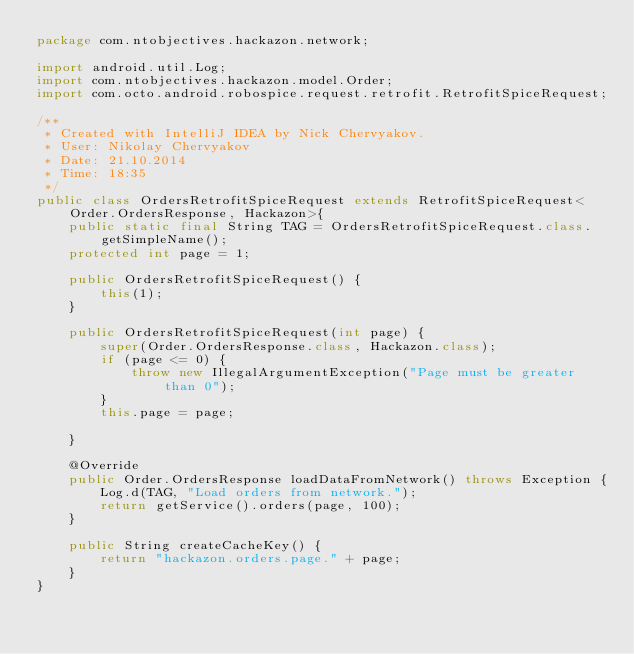Convert code to text. <code><loc_0><loc_0><loc_500><loc_500><_Java_>package com.ntobjectives.hackazon.network;

import android.util.Log;
import com.ntobjectives.hackazon.model.Order;
import com.octo.android.robospice.request.retrofit.RetrofitSpiceRequest;

/**
 * Created with IntelliJ IDEA by Nick Chervyakov.
 * User: Nikolay Chervyakov
 * Date: 21.10.2014
 * Time: 18:35
 */
public class OrdersRetrofitSpiceRequest extends RetrofitSpiceRequest<Order.OrdersResponse, Hackazon>{
    public static final String TAG = OrdersRetrofitSpiceRequest.class.getSimpleName();
    protected int page = 1;

    public OrdersRetrofitSpiceRequest() {
        this(1);
    }

    public OrdersRetrofitSpiceRequest(int page) {
        super(Order.OrdersResponse.class, Hackazon.class);
        if (page <= 0) {
            throw new IllegalArgumentException("Page must be greater than 0");
        }
        this.page = page;

    }

    @Override
    public Order.OrdersResponse loadDataFromNetwork() throws Exception {
        Log.d(TAG, "Load orders from network.");
        return getService().orders(page, 100);
    }

    public String createCacheKey() {
        return "hackazon.orders.page." + page;
    }
}
</code> 